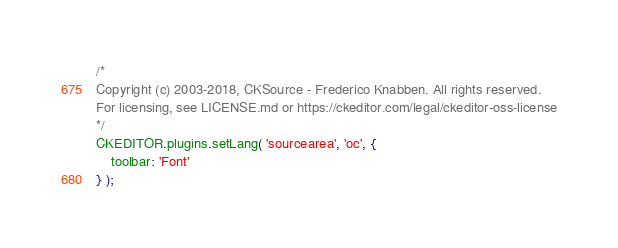Convert code to text. <code><loc_0><loc_0><loc_500><loc_500><_JavaScript_>/*
Copyright (c) 2003-2018, CKSource - Frederico Knabben. All rights reserved.
For licensing, see LICENSE.md or https://ckeditor.com/legal/ckeditor-oss-license
*/
CKEDITOR.plugins.setLang( 'sourcearea', 'oc', {
	toolbar: 'Font'
} );
</code> 